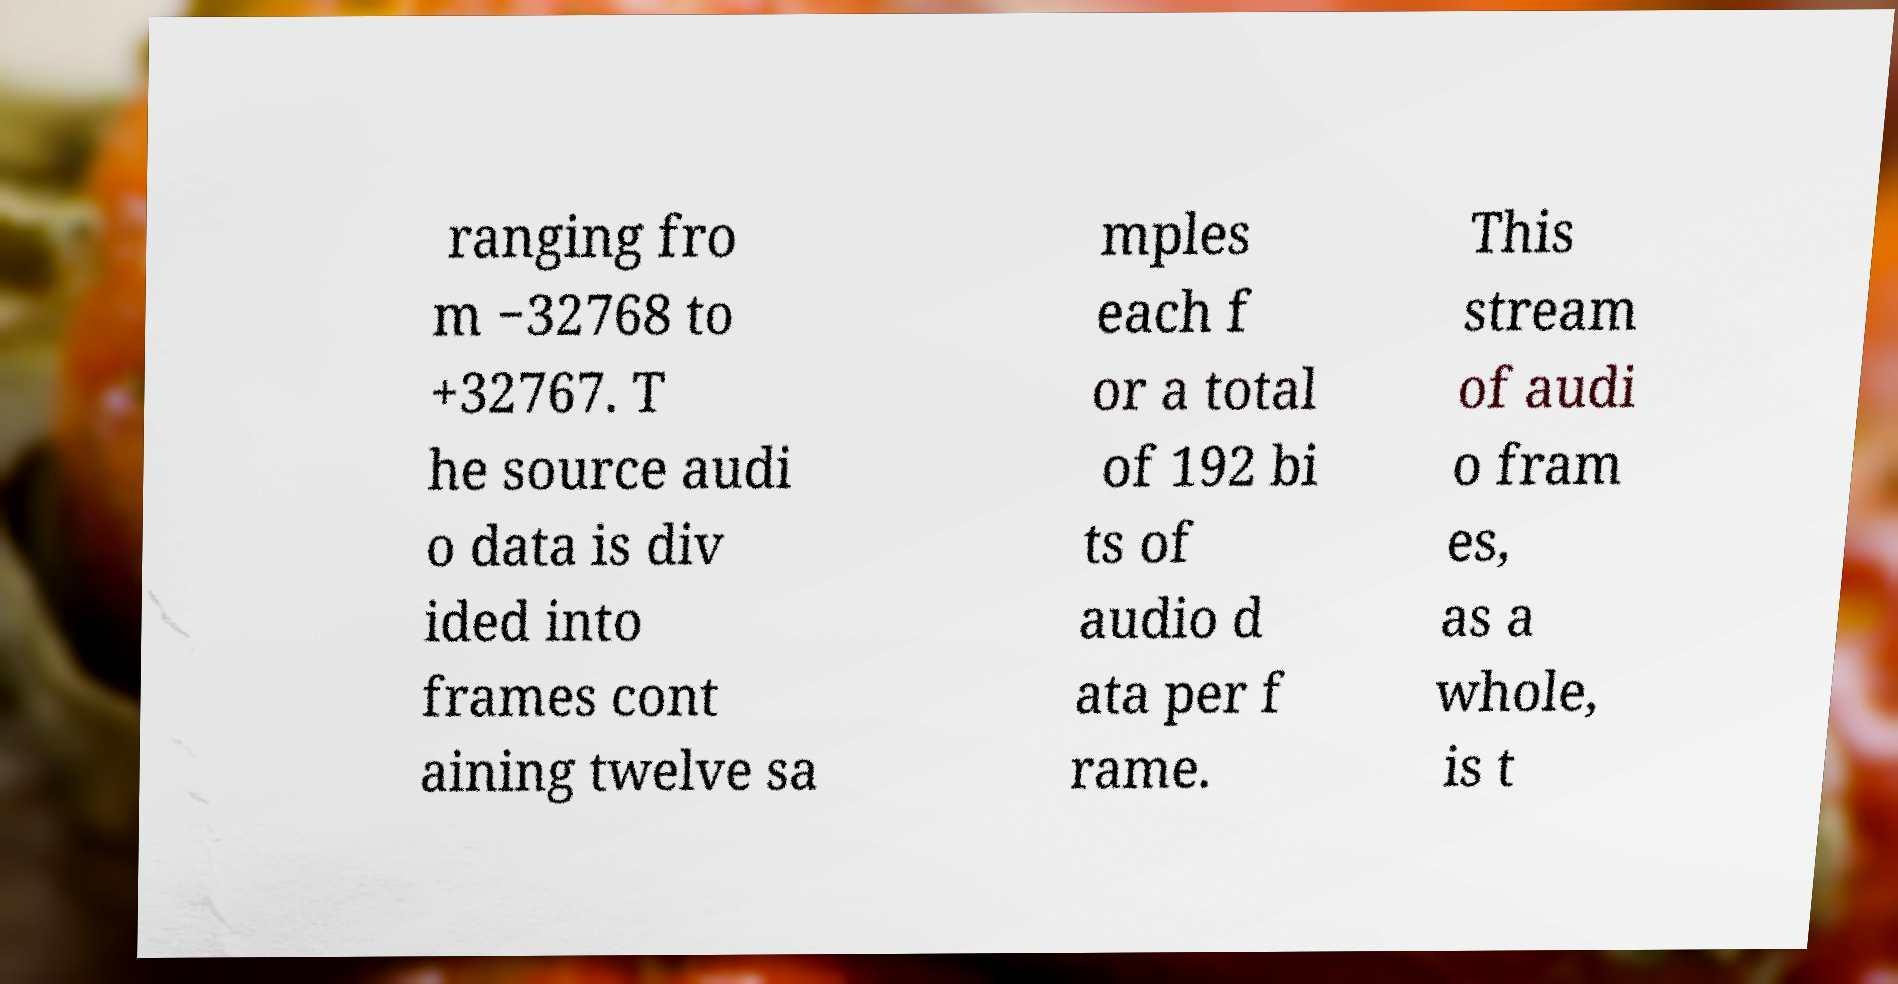There's text embedded in this image that I need extracted. Can you transcribe it verbatim? ranging fro m −32768 to +32767. T he source audi o data is div ided into frames cont aining twelve sa mples each f or a total of 192 bi ts of audio d ata per f rame. This stream of audi o fram es, as a whole, is t 